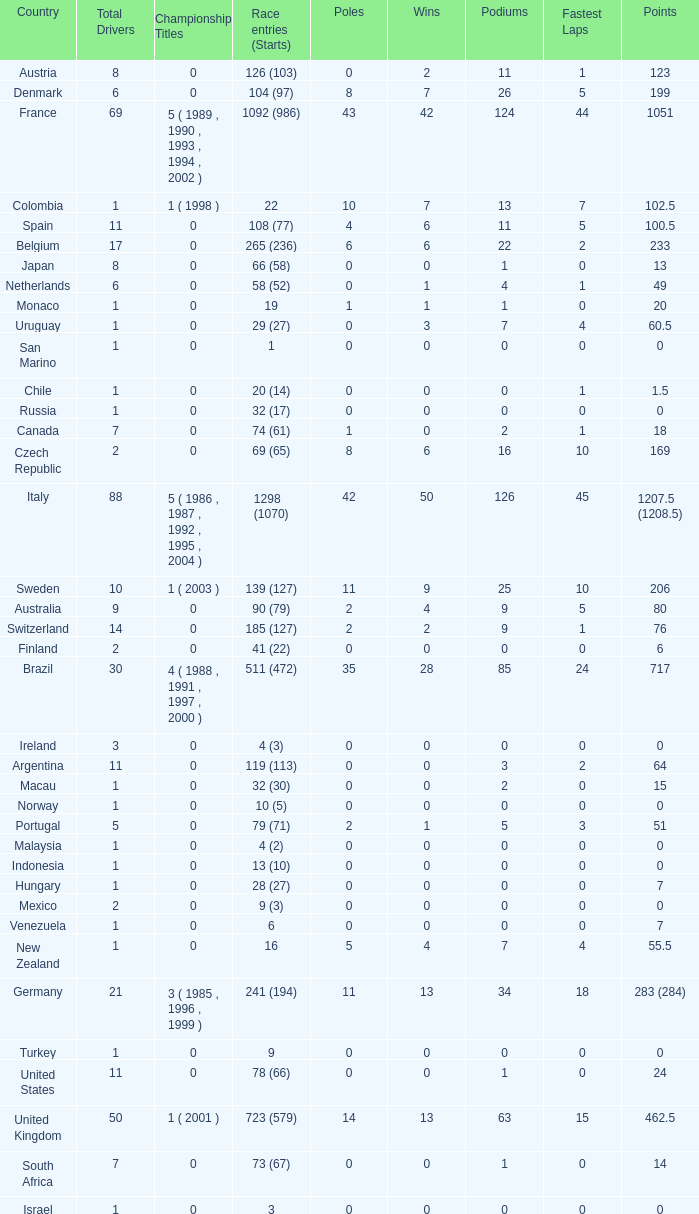How many fastest laps for the nation with 32 (30) entries and starts and fewer than 2 podiums? None. 